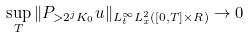Convert formula to latex. <formula><loc_0><loc_0><loc_500><loc_500>\sup _ { T } \| P _ { > 2 ^ { j } K _ { 0 } } u \| _ { L _ { t } ^ { \infty } L _ { x } ^ { 2 } ( [ 0 , T ] \times R ) } \rightarrow 0</formula> 